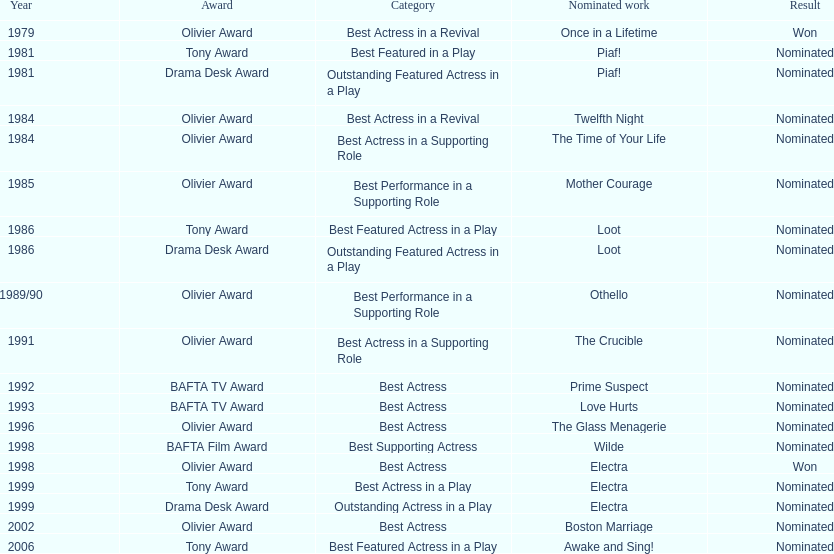For which theatrical production was wanamaker nominated for best actress in a revival in 1984? Twelfth Night. 